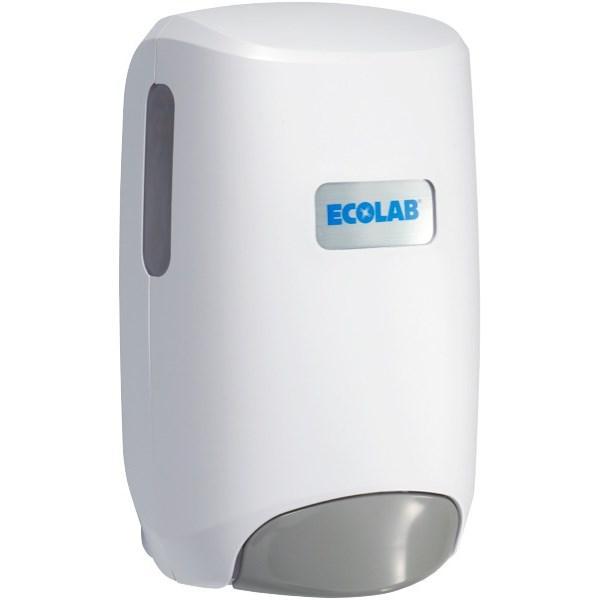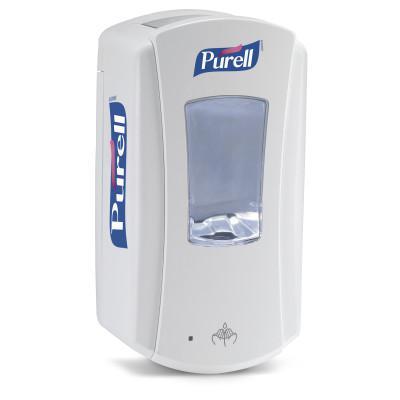The first image is the image on the left, the second image is the image on the right. Assess this claim about the two images: "The combined images include a wall-mount dispenser, a horizontal nozzle, and at least one chrome element.". Correct or not? Answer yes or no. No. The first image is the image on the left, the second image is the image on the right. Assess this claim about the two images: "There are two white dispensers.". Correct or not? Answer yes or no. Yes. 